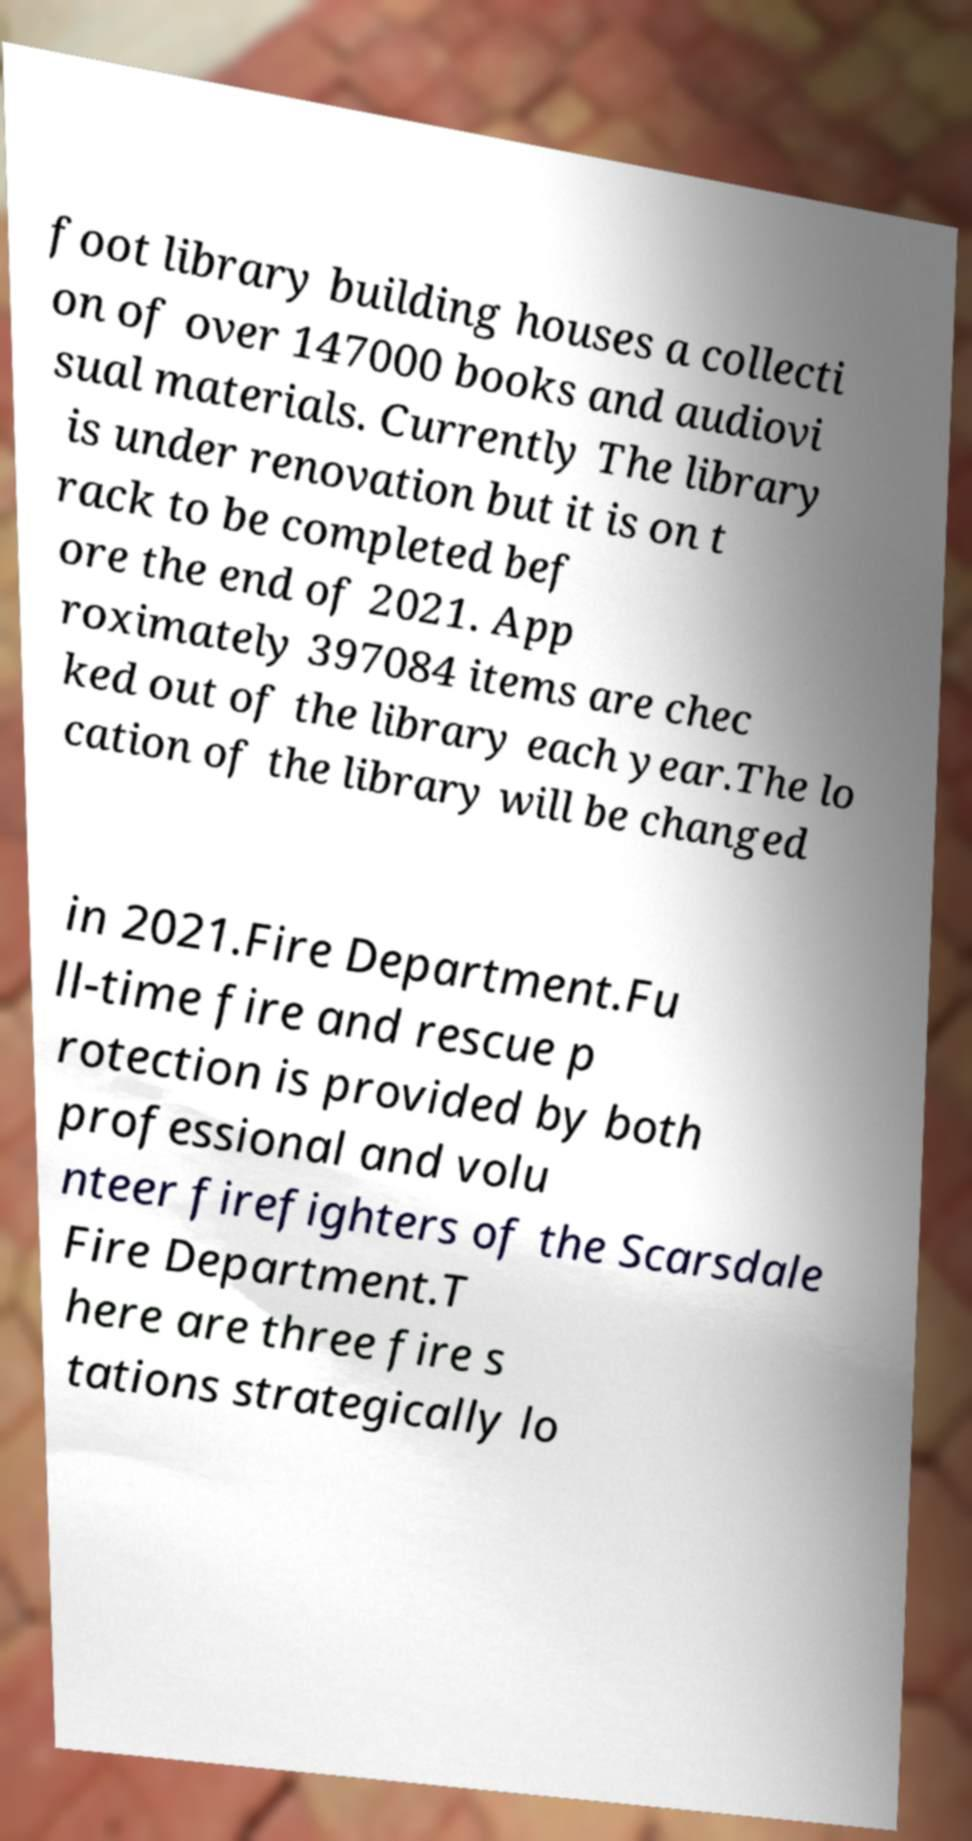Can you accurately transcribe the text from the provided image for me? foot library building houses a collecti on of over 147000 books and audiovi sual materials. Currently The library is under renovation but it is on t rack to be completed bef ore the end of 2021. App roximately 397084 items are chec ked out of the library each year.The lo cation of the library will be changed in 2021.Fire Department.Fu ll-time fire and rescue p rotection is provided by both professional and volu nteer firefighters of the Scarsdale Fire Department.T here are three fire s tations strategically lo 